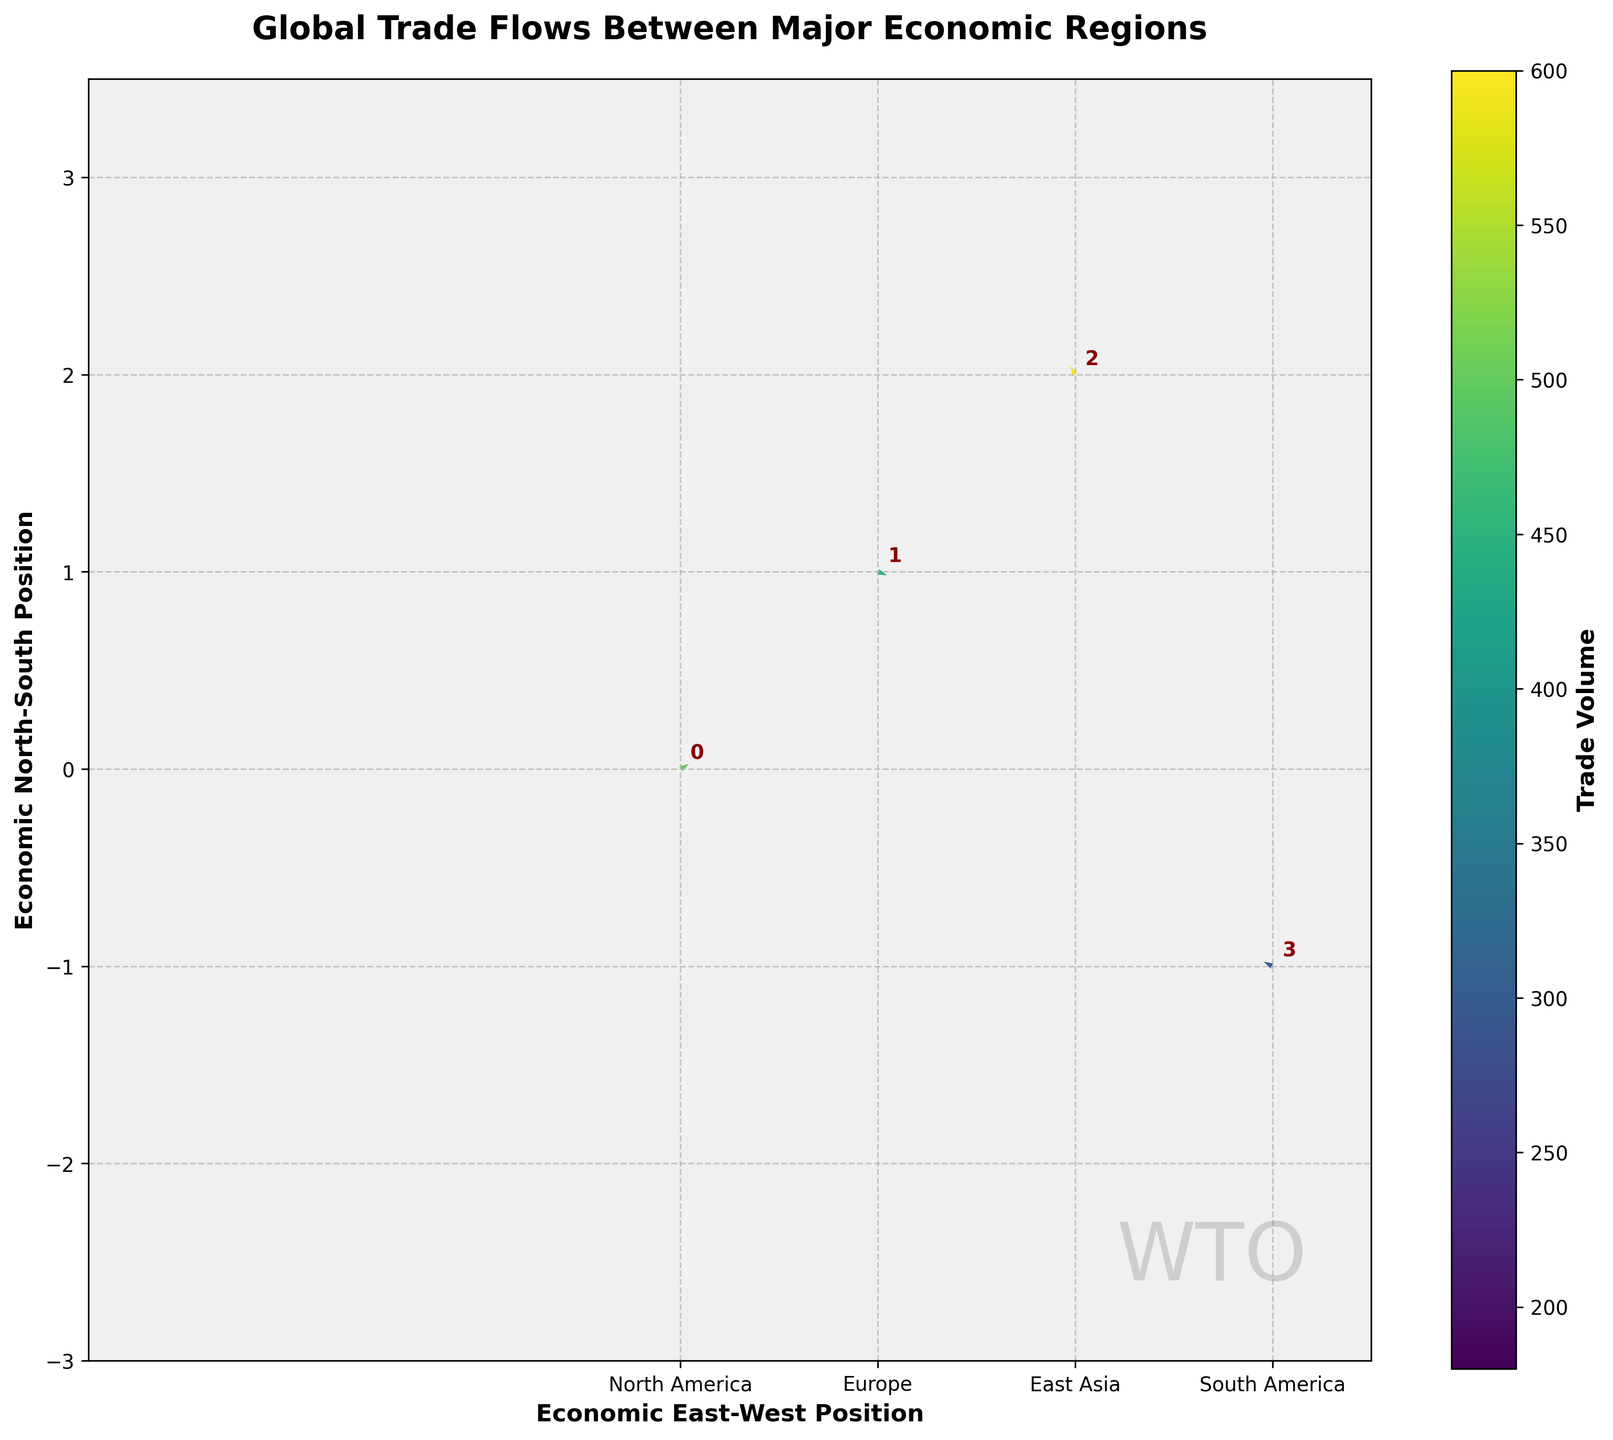How many economic regions are represented in the plot? By observing the number of data points labeled in the plot, we can count the total number of regions represented.
Answer: 10 Which region shows the largest trade volume? The regions are colored according to trade volume with a color bar for reference. The brightest (highest) color should indicate the largest trade volume.
Answer: East Asia Which region's trade direction is predominantly westward? By examining the direction of the arrows (u, v components) for westward trade (negative u direction), we can identify the region.
Answer: East Asia Which region's trade direction is primarily southward? By looking at the direction of the arrows (u, v components) for southward trade (negative v direction), we can determine the region.
Answer: Europe Compare the trade volumes of North America and Southeast Asia. Which one is higher? Utilize the color bar to compare the brightness of the colors representing North America and Southeast Asia; the brighter one indicates a higher trade volume.
Answer: North America Identify the regions that have trade directions pointing both eastward and southward. For both eastward and southward, the u component should be positive while the v component should be negative, helping identify the region(s).
Answer: Europe, Southeast Asia Which region has the lowest trade volume? The darkest shade observed in the plot indicates the lowest trade volume according to the color bar.
Answer: Central America What is the typical length of the arrows in the plot, and what does it signify? The length of the arrows is normalized to a scale providing visual reference-based direction and trend rather than absolute magnitude.
Answer: Varies based on normalized direction What relationship is depicted by the arrow directions in the plot? Arrow directions are influenced by (u, v) components, showing trade flow directions between different regions, both geographically east-west and north-south.
Answer: Trade direction Which region shows trade flow predominantly northeastward? By identifying arrows oriented toward the upper-right (positive u and v components) from the regions' origin, we can detect the region with primarily northeastward trade.
Answer: North America 